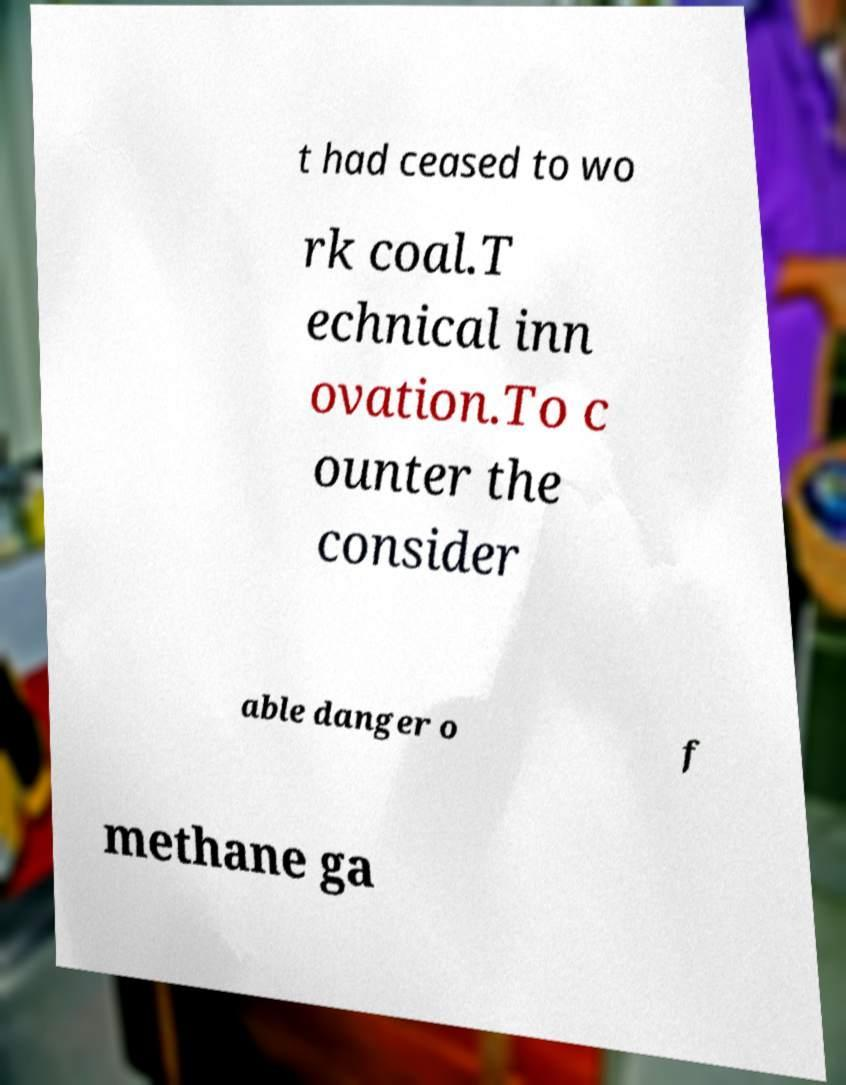Could you extract and type out the text from this image? t had ceased to wo rk coal.T echnical inn ovation.To c ounter the consider able danger o f methane ga 